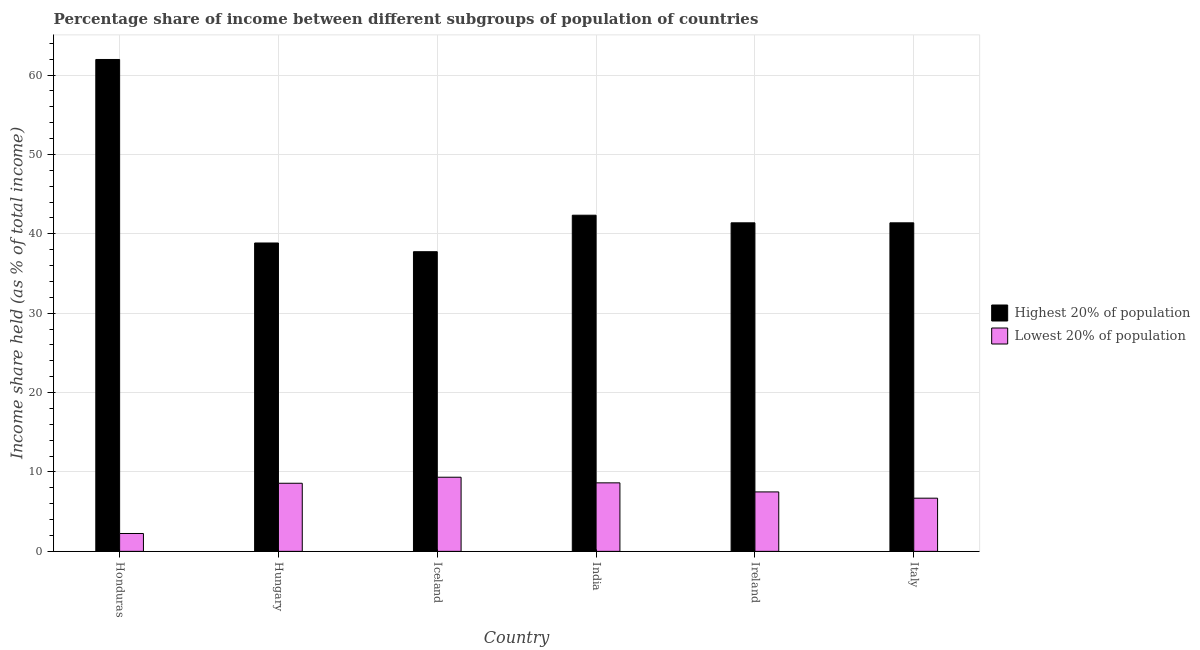Are the number of bars per tick equal to the number of legend labels?
Offer a very short reply. Yes. Are the number of bars on each tick of the X-axis equal?
Provide a succinct answer. Yes. How many bars are there on the 6th tick from the left?
Your answer should be very brief. 2. How many bars are there on the 5th tick from the right?
Provide a succinct answer. 2. What is the label of the 3rd group of bars from the left?
Ensure brevity in your answer.  Iceland. In how many cases, is the number of bars for a given country not equal to the number of legend labels?
Your answer should be very brief. 0. What is the income share held by highest 20% of the population in Iceland?
Offer a terse response. 37.75. Across all countries, what is the maximum income share held by highest 20% of the population?
Give a very brief answer. 61.97. Across all countries, what is the minimum income share held by highest 20% of the population?
Make the answer very short. 37.75. In which country was the income share held by highest 20% of the population maximum?
Offer a terse response. Honduras. What is the total income share held by lowest 20% of the population in the graph?
Your response must be concise. 42.99. What is the difference between the income share held by highest 20% of the population in Honduras and that in Italy?
Your answer should be very brief. 20.58. What is the difference between the income share held by lowest 20% of the population in Iceland and the income share held by highest 20% of the population in Hungary?
Provide a short and direct response. -29.51. What is the average income share held by lowest 20% of the population per country?
Provide a short and direct response. 7.17. What is the difference between the income share held by highest 20% of the population and income share held by lowest 20% of the population in Italy?
Provide a short and direct response. 34.69. In how many countries, is the income share held by lowest 20% of the population greater than 46 %?
Provide a short and direct response. 0. What is the ratio of the income share held by highest 20% of the population in Iceland to that in India?
Your answer should be very brief. 0.89. Is the income share held by lowest 20% of the population in Hungary less than that in Italy?
Make the answer very short. No. Is the difference between the income share held by lowest 20% of the population in Iceland and India greater than the difference between the income share held by highest 20% of the population in Iceland and India?
Make the answer very short. Yes. What is the difference between the highest and the second highest income share held by lowest 20% of the population?
Provide a succinct answer. 0.71. What is the difference between the highest and the lowest income share held by highest 20% of the population?
Your answer should be compact. 24.22. Is the sum of the income share held by lowest 20% of the population in Ireland and Italy greater than the maximum income share held by highest 20% of the population across all countries?
Provide a short and direct response. No. What does the 2nd bar from the left in India represents?
Your answer should be very brief. Lowest 20% of population. What does the 2nd bar from the right in Ireland represents?
Your response must be concise. Highest 20% of population. How many bars are there?
Your response must be concise. 12. Are all the bars in the graph horizontal?
Provide a short and direct response. No. What is the difference between two consecutive major ticks on the Y-axis?
Offer a very short reply. 10. Does the graph contain any zero values?
Your response must be concise. No. How many legend labels are there?
Keep it short and to the point. 2. What is the title of the graph?
Keep it short and to the point. Percentage share of income between different subgroups of population of countries. What is the label or title of the X-axis?
Provide a succinct answer. Country. What is the label or title of the Y-axis?
Your response must be concise. Income share held (as % of total income). What is the Income share held (as % of total income) of Highest 20% of population in Honduras?
Keep it short and to the point. 61.97. What is the Income share held (as % of total income) in Lowest 20% of population in Honduras?
Ensure brevity in your answer.  2.25. What is the Income share held (as % of total income) in Highest 20% of population in Hungary?
Offer a terse response. 38.85. What is the Income share held (as % of total income) of Lowest 20% of population in Hungary?
Provide a succinct answer. 8.58. What is the Income share held (as % of total income) of Highest 20% of population in Iceland?
Your answer should be very brief. 37.75. What is the Income share held (as % of total income) in Lowest 20% of population in Iceland?
Your answer should be very brief. 9.34. What is the Income share held (as % of total income) in Highest 20% of population in India?
Your answer should be compact. 42.35. What is the Income share held (as % of total income) of Lowest 20% of population in India?
Make the answer very short. 8.63. What is the Income share held (as % of total income) in Highest 20% of population in Ireland?
Make the answer very short. 41.39. What is the Income share held (as % of total income) in Lowest 20% of population in Ireland?
Offer a very short reply. 7.49. What is the Income share held (as % of total income) of Highest 20% of population in Italy?
Your response must be concise. 41.39. Across all countries, what is the maximum Income share held (as % of total income) of Highest 20% of population?
Provide a short and direct response. 61.97. Across all countries, what is the maximum Income share held (as % of total income) in Lowest 20% of population?
Provide a succinct answer. 9.34. Across all countries, what is the minimum Income share held (as % of total income) in Highest 20% of population?
Offer a terse response. 37.75. Across all countries, what is the minimum Income share held (as % of total income) in Lowest 20% of population?
Your response must be concise. 2.25. What is the total Income share held (as % of total income) in Highest 20% of population in the graph?
Your answer should be very brief. 263.7. What is the total Income share held (as % of total income) of Lowest 20% of population in the graph?
Your answer should be compact. 42.99. What is the difference between the Income share held (as % of total income) in Highest 20% of population in Honduras and that in Hungary?
Your answer should be very brief. 23.12. What is the difference between the Income share held (as % of total income) in Lowest 20% of population in Honduras and that in Hungary?
Provide a succinct answer. -6.33. What is the difference between the Income share held (as % of total income) of Highest 20% of population in Honduras and that in Iceland?
Keep it short and to the point. 24.22. What is the difference between the Income share held (as % of total income) of Lowest 20% of population in Honduras and that in Iceland?
Your answer should be very brief. -7.09. What is the difference between the Income share held (as % of total income) in Highest 20% of population in Honduras and that in India?
Your answer should be very brief. 19.62. What is the difference between the Income share held (as % of total income) in Lowest 20% of population in Honduras and that in India?
Make the answer very short. -6.38. What is the difference between the Income share held (as % of total income) of Highest 20% of population in Honduras and that in Ireland?
Make the answer very short. 20.58. What is the difference between the Income share held (as % of total income) of Lowest 20% of population in Honduras and that in Ireland?
Keep it short and to the point. -5.24. What is the difference between the Income share held (as % of total income) of Highest 20% of population in Honduras and that in Italy?
Offer a very short reply. 20.58. What is the difference between the Income share held (as % of total income) in Lowest 20% of population in Honduras and that in Italy?
Give a very brief answer. -4.45. What is the difference between the Income share held (as % of total income) in Highest 20% of population in Hungary and that in Iceland?
Keep it short and to the point. 1.1. What is the difference between the Income share held (as % of total income) in Lowest 20% of population in Hungary and that in Iceland?
Provide a succinct answer. -0.76. What is the difference between the Income share held (as % of total income) in Lowest 20% of population in Hungary and that in India?
Provide a succinct answer. -0.05. What is the difference between the Income share held (as % of total income) in Highest 20% of population in Hungary and that in Ireland?
Provide a short and direct response. -2.54. What is the difference between the Income share held (as % of total income) in Lowest 20% of population in Hungary and that in Ireland?
Give a very brief answer. 1.09. What is the difference between the Income share held (as % of total income) of Highest 20% of population in Hungary and that in Italy?
Make the answer very short. -2.54. What is the difference between the Income share held (as % of total income) in Lowest 20% of population in Hungary and that in Italy?
Ensure brevity in your answer.  1.88. What is the difference between the Income share held (as % of total income) of Lowest 20% of population in Iceland and that in India?
Your answer should be compact. 0.71. What is the difference between the Income share held (as % of total income) of Highest 20% of population in Iceland and that in Ireland?
Your answer should be very brief. -3.64. What is the difference between the Income share held (as % of total income) of Lowest 20% of population in Iceland and that in Ireland?
Your answer should be compact. 1.85. What is the difference between the Income share held (as % of total income) in Highest 20% of population in Iceland and that in Italy?
Make the answer very short. -3.64. What is the difference between the Income share held (as % of total income) of Lowest 20% of population in Iceland and that in Italy?
Give a very brief answer. 2.64. What is the difference between the Income share held (as % of total income) in Lowest 20% of population in India and that in Ireland?
Provide a succinct answer. 1.14. What is the difference between the Income share held (as % of total income) of Lowest 20% of population in India and that in Italy?
Provide a short and direct response. 1.93. What is the difference between the Income share held (as % of total income) of Highest 20% of population in Ireland and that in Italy?
Offer a very short reply. 0. What is the difference between the Income share held (as % of total income) in Lowest 20% of population in Ireland and that in Italy?
Offer a terse response. 0.79. What is the difference between the Income share held (as % of total income) of Highest 20% of population in Honduras and the Income share held (as % of total income) of Lowest 20% of population in Hungary?
Provide a succinct answer. 53.39. What is the difference between the Income share held (as % of total income) of Highest 20% of population in Honduras and the Income share held (as % of total income) of Lowest 20% of population in Iceland?
Give a very brief answer. 52.63. What is the difference between the Income share held (as % of total income) in Highest 20% of population in Honduras and the Income share held (as % of total income) in Lowest 20% of population in India?
Keep it short and to the point. 53.34. What is the difference between the Income share held (as % of total income) in Highest 20% of population in Honduras and the Income share held (as % of total income) in Lowest 20% of population in Ireland?
Your answer should be very brief. 54.48. What is the difference between the Income share held (as % of total income) in Highest 20% of population in Honduras and the Income share held (as % of total income) in Lowest 20% of population in Italy?
Provide a succinct answer. 55.27. What is the difference between the Income share held (as % of total income) of Highest 20% of population in Hungary and the Income share held (as % of total income) of Lowest 20% of population in Iceland?
Offer a very short reply. 29.51. What is the difference between the Income share held (as % of total income) in Highest 20% of population in Hungary and the Income share held (as % of total income) in Lowest 20% of population in India?
Keep it short and to the point. 30.22. What is the difference between the Income share held (as % of total income) of Highest 20% of population in Hungary and the Income share held (as % of total income) of Lowest 20% of population in Ireland?
Make the answer very short. 31.36. What is the difference between the Income share held (as % of total income) in Highest 20% of population in Hungary and the Income share held (as % of total income) in Lowest 20% of population in Italy?
Your response must be concise. 32.15. What is the difference between the Income share held (as % of total income) of Highest 20% of population in Iceland and the Income share held (as % of total income) of Lowest 20% of population in India?
Make the answer very short. 29.12. What is the difference between the Income share held (as % of total income) of Highest 20% of population in Iceland and the Income share held (as % of total income) of Lowest 20% of population in Ireland?
Offer a terse response. 30.26. What is the difference between the Income share held (as % of total income) in Highest 20% of population in Iceland and the Income share held (as % of total income) in Lowest 20% of population in Italy?
Your answer should be very brief. 31.05. What is the difference between the Income share held (as % of total income) in Highest 20% of population in India and the Income share held (as % of total income) in Lowest 20% of population in Ireland?
Your answer should be very brief. 34.86. What is the difference between the Income share held (as % of total income) in Highest 20% of population in India and the Income share held (as % of total income) in Lowest 20% of population in Italy?
Give a very brief answer. 35.65. What is the difference between the Income share held (as % of total income) of Highest 20% of population in Ireland and the Income share held (as % of total income) of Lowest 20% of population in Italy?
Provide a succinct answer. 34.69. What is the average Income share held (as % of total income) of Highest 20% of population per country?
Your response must be concise. 43.95. What is the average Income share held (as % of total income) in Lowest 20% of population per country?
Offer a terse response. 7.17. What is the difference between the Income share held (as % of total income) of Highest 20% of population and Income share held (as % of total income) of Lowest 20% of population in Honduras?
Offer a very short reply. 59.72. What is the difference between the Income share held (as % of total income) of Highest 20% of population and Income share held (as % of total income) of Lowest 20% of population in Hungary?
Ensure brevity in your answer.  30.27. What is the difference between the Income share held (as % of total income) of Highest 20% of population and Income share held (as % of total income) of Lowest 20% of population in Iceland?
Give a very brief answer. 28.41. What is the difference between the Income share held (as % of total income) in Highest 20% of population and Income share held (as % of total income) in Lowest 20% of population in India?
Keep it short and to the point. 33.72. What is the difference between the Income share held (as % of total income) of Highest 20% of population and Income share held (as % of total income) of Lowest 20% of population in Ireland?
Give a very brief answer. 33.9. What is the difference between the Income share held (as % of total income) of Highest 20% of population and Income share held (as % of total income) of Lowest 20% of population in Italy?
Keep it short and to the point. 34.69. What is the ratio of the Income share held (as % of total income) in Highest 20% of population in Honduras to that in Hungary?
Keep it short and to the point. 1.6. What is the ratio of the Income share held (as % of total income) of Lowest 20% of population in Honduras to that in Hungary?
Your answer should be compact. 0.26. What is the ratio of the Income share held (as % of total income) in Highest 20% of population in Honduras to that in Iceland?
Offer a terse response. 1.64. What is the ratio of the Income share held (as % of total income) of Lowest 20% of population in Honduras to that in Iceland?
Provide a succinct answer. 0.24. What is the ratio of the Income share held (as % of total income) in Highest 20% of population in Honduras to that in India?
Your response must be concise. 1.46. What is the ratio of the Income share held (as % of total income) of Lowest 20% of population in Honduras to that in India?
Ensure brevity in your answer.  0.26. What is the ratio of the Income share held (as % of total income) of Highest 20% of population in Honduras to that in Ireland?
Keep it short and to the point. 1.5. What is the ratio of the Income share held (as % of total income) of Lowest 20% of population in Honduras to that in Ireland?
Keep it short and to the point. 0.3. What is the ratio of the Income share held (as % of total income) of Highest 20% of population in Honduras to that in Italy?
Your answer should be very brief. 1.5. What is the ratio of the Income share held (as % of total income) of Lowest 20% of population in Honduras to that in Italy?
Keep it short and to the point. 0.34. What is the ratio of the Income share held (as % of total income) of Highest 20% of population in Hungary to that in Iceland?
Your response must be concise. 1.03. What is the ratio of the Income share held (as % of total income) of Lowest 20% of population in Hungary to that in Iceland?
Offer a very short reply. 0.92. What is the ratio of the Income share held (as % of total income) of Highest 20% of population in Hungary to that in India?
Your answer should be very brief. 0.92. What is the ratio of the Income share held (as % of total income) in Lowest 20% of population in Hungary to that in India?
Ensure brevity in your answer.  0.99. What is the ratio of the Income share held (as % of total income) in Highest 20% of population in Hungary to that in Ireland?
Give a very brief answer. 0.94. What is the ratio of the Income share held (as % of total income) in Lowest 20% of population in Hungary to that in Ireland?
Provide a short and direct response. 1.15. What is the ratio of the Income share held (as % of total income) of Highest 20% of population in Hungary to that in Italy?
Ensure brevity in your answer.  0.94. What is the ratio of the Income share held (as % of total income) of Lowest 20% of population in Hungary to that in Italy?
Ensure brevity in your answer.  1.28. What is the ratio of the Income share held (as % of total income) in Highest 20% of population in Iceland to that in India?
Provide a short and direct response. 0.89. What is the ratio of the Income share held (as % of total income) in Lowest 20% of population in Iceland to that in India?
Offer a very short reply. 1.08. What is the ratio of the Income share held (as % of total income) of Highest 20% of population in Iceland to that in Ireland?
Give a very brief answer. 0.91. What is the ratio of the Income share held (as % of total income) of Lowest 20% of population in Iceland to that in Ireland?
Your response must be concise. 1.25. What is the ratio of the Income share held (as % of total income) in Highest 20% of population in Iceland to that in Italy?
Your answer should be compact. 0.91. What is the ratio of the Income share held (as % of total income) of Lowest 20% of population in Iceland to that in Italy?
Your answer should be compact. 1.39. What is the ratio of the Income share held (as % of total income) in Highest 20% of population in India to that in Ireland?
Ensure brevity in your answer.  1.02. What is the ratio of the Income share held (as % of total income) in Lowest 20% of population in India to that in Ireland?
Offer a terse response. 1.15. What is the ratio of the Income share held (as % of total income) in Highest 20% of population in India to that in Italy?
Provide a short and direct response. 1.02. What is the ratio of the Income share held (as % of total income) in Lowest 20% of population in India to that in Italy?
Provide a succinct answer. 1.29. What is the ratio of the Income share held (as % of total income) of Highest 20% of population in Ireland to that in Italy?
Your answer should be compact. 1. What is the ratio of the Income share held (as % of total income) in Lowest 20% of population in Ireland to that in Italy?
Make the answer very short. 1.12. What is the difference between the highest and the second highest Income share held (as % of total income) of Highest 20% of population?
Offer a terse response. 19.62. What is the difference between the highest and the second highest Income share held (as % of total income) in Lowest 20% of population?
Offer a terse response. 0.71. What is the difference between the highest and the lowest Income share held (as % of total income) of Highest 20% of population?
Your response must be concise. 24.22. What is the difference between the highest and the lowest Income share held (as % of total income) in Lowest 20% of population?
Offer a very short reply. 7.09. 